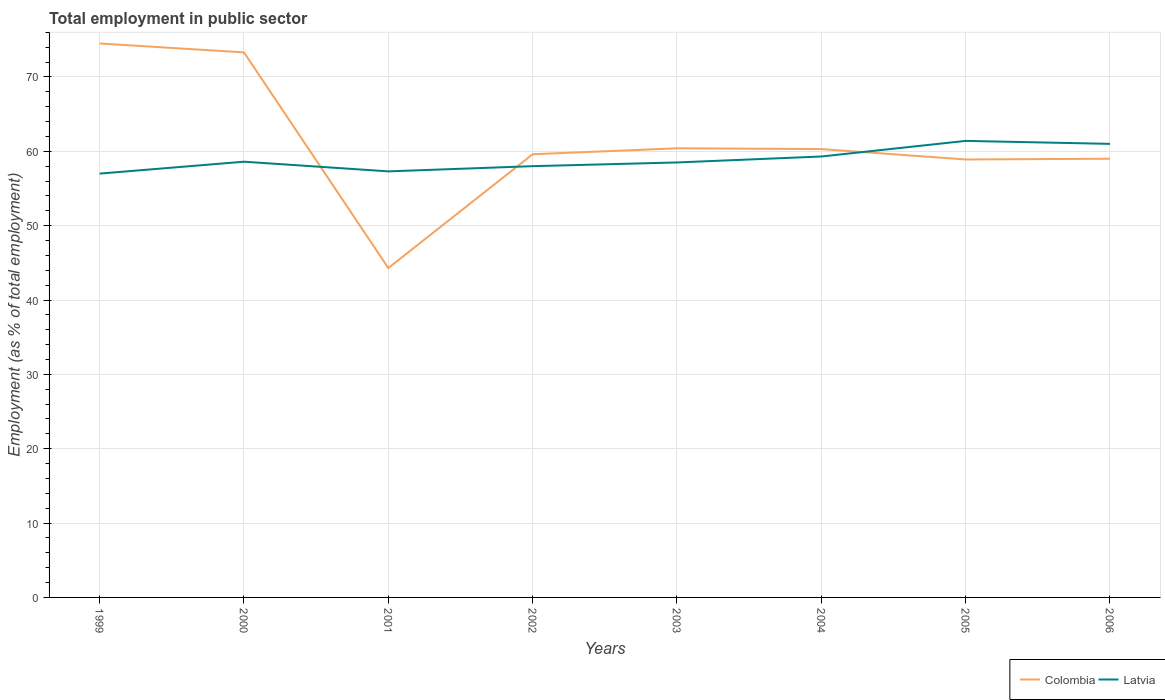How many different coloured lines are there?
Make the answer very short. 2. In which year was the employment in public sector in Colombia maximum?
Offer a very short reply. 2001. What is the total employment in public sector in Latvia in the graph?
Give a very brief answer. -1.6. What is the difference between the highest and the second highest employment in public sector in Colombia?
Offer a terse response. 30.2. What is the difference between the highest and the lowest employment in public sector in Colombia?
Your response must be concise. 2. Is the employment in public sector in Colombia strictly greater than the employment in public sector in Latvia over the years?
Make the answer very short. No. How many years are there in the graph?
Provide a short and direct response. 8. What is the difference between two consecutive major ticks on the Y-axis?
Give a very brief answer. 10. Are the values on the major ticks of Y-axis written in scientific E-notation?
Your answer should be compact. No. Does the graph contain any zero values?
Offer a very short reply. No. Does the graph contain grids?
Provide a short and direct response. Yes. Where does the legend appear in the graph?
Your answer should be compact. Bottom right. How many legend labels are there?
Ensure brevity in your answer.  2. What is the title of the graph?
Ensure brevity in your answer.  Total employment in public sector. Does "United Kingdom" appear as one of the legend labels in the graph?
Make the answer very short. No. What is the label or title of the X-axis?
Your response must be concise. Years. What is the label or title of the Y-axis?
Keep it short and to the point. Employment (as % of total employment). What is the Employment (as % of total employment) of Colombia in 1999?
Keep it short and to the point. 74.5. What is the Employment (as % of total employment) of Colombia in 2000?
Your answer should be very brief. 73.3. What is the Employment (as % of total employment) in Latvia in 2000?
Your response must be concise. 58.6. What is the Employment (as % of total employment) of Colombia in 2001?
Keep it short and to the point. 44.3. What is the Employment (as % of total employment) of Latvia in 2001?
Provide a short and direct response. 57.3. What is the Employment (as % of total employment) in Colombia in 2002?
Your response must be concise. 59.6. What is the Employment (as % of total employment) in Latvia in 2002?
Provide a succinct answer. 58. What is the Employment (as % of total employment) in Colombia in 2003?
Your answer should be very brief. 60.4. What is the Employment (as % of total employment) in Latvia in 2003?
Give a very brief answer. 58.5. What is the Employment (as % of total employment) in Colombia in 2004?
Keep it short and to the point. 60.3. What is the Employment (as % of total employment) of Latvia in 2004?
Ensure brevity in your answer.  59.3. What is the Employment (as % of total employment) of Colombia in 2005?
Give a very brief answer. 58.9. What is the Employment (as % of total employment) of Latvia in 2005?
Make the answer very short. 61.4. What is the Employment (as % of total employment) in Latvia in 2006?
Offer a terse response. 61. Across all years, what is the maximum Employment (as % of total employment) in Colombia?
Offer a terse response. 74.5. Across all years, what is the maximum Employment (as % of total employment) in Latvia?
Provide a short and direct response. 61.4. Across all years, what is the minimum Employment (as % of total employment) in Colombia?
Your answer should be compact. 44.3. What is the total Employment (as % of total employment) in Colombia in the graph?
Offer a very short reply. 490.3. What is the total Employment (as % of total employment) in Latvia in the graph?
Offer a very short reply. 471.1. What is the difference between the Employment (as % of total employment) in Latvia in 1999 and that in 2000?
Provide a succinct answer. -1.6. What is the difference between the Employment (as % of total employment) of Colombia in 1999 and that in 2001?
Offer a terse response. 30.2. What is the difference between the Employment (as % of total employment) of Latvia in 1999 and that in 2002?
Provide a short and direct response. -1. What is the difference between the Employment (as % of total employment) of Colombia in 1999 and that in 2004?
Your answer should be compact. 14.2. What is the difference between the Employment (as % of total employment) in Colombia in 1999 and that in 2005?
Make the answer very short. 15.6. What is the difference between the Employment (as % of total employment) in Colombia in 1999 and that in 2006?
Your answer should be compact. 15.5. What is the difference between the Employment (as % of total employment) of Colombia in 2000 and that in 2004?
Make the answer very short. 13. What is the difference between the Employment (as % of total employment) in Latvia in 2000 and that in 2005?
Your answer should be compact. -2.8. What is the difference between the Employment (as % of total employment) of Colombia in 2000 and that in 2006?
Give a very brief answer. 14.3. What is the difference between the Employment (as % of total employment) in Latvia in 2000 and that in 2006?
Make the answer very short. -2.4. What is the difference between the Employment (as % of total employment) of Colombia in 2001 and that in 2002?
Ensure brevity in your answer.  -15.3. What is the difference between the Employment (as % of total employment) of Colombia in 2001 and that in 2003?
Your answer should be very brief. -16.1. What is the difference between the Employment (as % of total employment) of Colombia in 2001 and that in 2004?
Ensure brevity in your answer.  -16. What is the difference between the Employment (as % of total employment) in Colombia in 2001 and that in 2005?
Offer a terse response. -14.6. What is the difference between the Employment (as % of total employment) of Colombia in 2001 and that in 2006?
Ensure brevity in your answer.  -14.7. What is the difference between the Employment (as % of total employment) in Latvia in 2001 and that in 2006?
Offer a very short reply. -3.7. What is the difference between the Employment (as % of total employment) of Latvia in 2002 and that in 2003?
Offer a terse response. -0.5. What is the difference between the Employment (as % of total employment) of Colombia in 2002 and that in 2006?
Make the answer very short. 0.6. What is the difference between the Employment (as % of total employment) of Latvia in 2002 and that in 2006?
Provide a succinct answer. -3. What is the difference between the Employment (as % of total employment) of Latvia in 2003 and that in 2004?
Offer a very short reply. -0.8. What is the difference between the Employment (as % of total employment) of Latvia in 2003 and that in 2005?
Give a very brief answer. -2.9. What is the difference between the Employment (as % of total employment) in Latvia in 2003 and that in 2006?
Provide a short and direct response. -2.5. What is the difference between the Employment (as % of total employment) of Colombia in 2004 and that in 2005?
Make the answer very short. 1.4. What is the difference between the Employment (as % of total employment) in Latvia in 2004 and that in 2005?
Ensure brevity in your answer.  -2.1. What is the difference between the Employment (as % of total employment) of Latvia in 2004 and that in 2006?
Your answer should be compact. -1.7. What is the difference between the Employment (as % of total employment) in Colombia in 2005 and that in 2006?
Offer a terse response. -0.1. What is the difference between the Employment (as % of total employment) of Latvia in 2005 and that in 2006?
Offer a very short reply. 0.4. What is the difference between the Employment (as % of total employment) of Colombia in 1999 and the Employment (as % of total employment) of Latvia in 2001?
Provide a short and direct response. 17.2. What is the difference between the Employment (as % of total employment) of Colombia in 1999 and the Employment (as % of total employment) of Latvia in 2005?
Keep it short and to the point. 13.1. What is the difference between the Employment (as % of total employment) of Colombia in 2000 and the Employment (as % of total employment) of Latvia in 2003?
Offer a very short reply. 14.8. What is the difference between the Employment (as % of total employment) in Colombia in 2000 and the Employment (as % of total employment) in Latvia in 2004?
Provide a short and direct response. 14. What is the difference between the Employment (as % of total employment) in Colombia in 2000 and the Employment (as % of total employment) in Latvia in 2005?
Give a very brief answer. 11.9. What is the difference between the Employment (as % of total employment) of Colombia in 2000 and the Employment (as % of total employment) of Latvia in 2006?
Keep it short and to the point. 12.3. What is the difference between the Employment (as % of total employment) of Colombia in 2001 and the Employment (as % of total employment) of Latvia in 2002?
Your answer should be very brief. -13.7. What is the difference between the Employment (as % of total employment) of Colombia in 2001 and the Employment (as % of total employment) of Latvia in 2005?
Offer a very short reply. -17.1. What is the difference between the Employment (as % of total employment) of Colombia in 2001 and the Employment (as % of total employment) of Latvia in 2006?
Ensure brevity in your answer.  -16.7. What is the difference between the Employment (as % of total employment) in Colombia in 2002 and the Employment (as % of total employment) in Latvia in 2004?
Your answer should be very brief. 0.3. What is the difference between the Employment (as % of total employment) of Colombia in 2002 and the Employment (as % of total employment) of Latvia in 2005?
Offer a very short reply. -1.8. What is the difference between the Employment (as % of total employment) of Colombia in 2002 and the Employment (as % of total employment) of Latvia in 2006?
Ensure brevity in your answer.  -1.4. What is the difference between the Employment (as % of total employment) in Colombia in 2003 and the Employment (as % of total employment) in Latvia in 2004?
Provide a short and direct response. 1.1. What is the average Employment (as % of total employment) of Colombia per year?
Your answer should be very brief. 61.29. What is the average Employment (as % of total employment) of Latvia per year?
Offer a terse response. 58.89. In the year 1999, what is the difference between the Employment (as % of total employment) in Colombia and Employment (as % of total employment) in Latvia?
Keep it short and to the point. 17.5. In the year 2002, what is the difference between the Employment (as % of total employment) of Colombia and Employment (as % of total employment) of Latvia?
Your answer should be compact. 1.6. In the year 2004, what is the difference between the Employment (as % of total employment) in Colombia and Employment (as % of total employment) in Latvia?
Your answer should be very brief. 1. What is the ratio of the Employment (as % of total employment) in Colombia in 1999 to that in 2000?
Ensure brevity in your answer.  1.02. What is the ratio of the Employment (as % of total employment) in Latvia in 1999 to that in 2000?
Make the answer very short. 0.97. What is the ratio of the Employment (as % of total employment) of Colombia in 1999 to that in 2001?
Make the answer very short. 1.68. What is the ratio of the Employment (as % of total employment) of Colombia in 1999 to that in 2002?
Offer a terse response. 1.25. What is the ratio of the Employment (as % of total employment) of Latvia in 1999 to that in 2002?
Offer a terse response. 0.98. What is the ratio of the Employment (as % of total employment) of Colombia in 1999 to that in 2003?
Provide a succinct answer. 1.23. What is the ratio of the Employment (as % of total employment) of Latvia in 1999 to that in 2003?
Your answer should be compact. 0.97. What is the ratio of the Employment (as % of total employment) of Colombia in 1999 to that in 2004?
Provide a succinct answer. 1.24. What is the ratio of the Employment (as % of total employment) of Latvia in 1999 to that in 2004?
Make the answer very short. 0.96. What is the ratio of the Employment (as % of total employment) in Colombia in 1999 to that in 2005?
Your response must be concise. 1.26. What is the ratio of the Employment (as % of total employment) of Latvia in 1999 to that in 2005?
Give a very brief answer. 0.93. What is the ratio of the Employment (as % of total employment) in Colombia in 1999 to that in 2006?
Provide a succinct answer. 1.26. What is the ratio of the Employment (as % of total employment) in Latvia in 1999 to that in 2006?
Provide a short and direct response. 0.93. What is the ratio of the Employment (as % of total employment) in Colombia in 2000 to that in 2001?
Offer a very short reply. 1.65. What is the ratio of the Employment (as % of total employment) of Latvia in 2000 to that in 2001?
Make the answer very short. 1.02. What is the ratio of the Employment (as % of total employment) in Colombia in 2000 to that in 2002?
Make the answer very short. 1.23. What is the ratio of the Employment (as % of total employment) of Latvia in 2000 to that in 2002?
Your answer should be compact. 1.01. What is the ratio of the Employment (as % of total employment) in Colombia in 2000 to that in 2003?
Make the answer very short. 1.21. What is the ratio of the Employment (as % of total employment) of Latvia in 2000 to that in 2003?
Your answer should be very brief. 1. What is the ratio of the Employment (as % of total employment) in Colombia in 2000 to that in 2004?
Make the answer very short. 1.22. What is the ratio of the Employment (as % of total employment) in Latvia in 2000 to that in 2004?
Ensure brevity in your answer.  0.99. What is the ratio of the Employment (as % of total employment) in Colombia in 2000 to that in 2005?
Ensure brevity in your answer.  1.24. What is the ratio of the Employment (as % of total employment) in Latvia in 2000 to that in 2005?
Provide a succinct answer. 0.95. What is the ratio of the Employment (as % of total employment) in Colombia in 2000 to that in 2006?
Make the answer very short. 1.24. What is the ratio of the Employment (as % of total employment) of Latvia in 2000 to that in 2006?
Your answer should be very brief. 0.96. What is the ratio of the Employment (as % of total employment) in Colombia in 2001 to that in 2002?
Provide a succinct answer. 0.74. What is the ratio of the Employment (as % of total employment) in Latvia in 2001 to that in 2002?
Offer a very short reply. 0.99. What is the ratio of the Employment (as % of total employment) of Colombia in 2001 to that in 2003?
Make the answer very short. 0.73. What is the ratio of the Employment (as % of total employment) of Latvia in 2001 to that in 2003?
Provide a short and direct response. 0.98. What is the ratio of the Employment (as % of total employment) in Colombia in 2001 to that in 2004?
Provide a short and direct response. 0.73. What is the ratio of the Employment (as % of total employment) of Latvia in 2001 to that in 2004?
Provide a short and direct response. 0.97. What is the ratio of the Employment (as % of total employment) of Colombia in 2001 to that in 2005?
Your answer should be compact. 0.75. What is the ratio of the Employment (as % of total employment) in Latvia in 2001 to that in 2005?
Your answer should be very brief. 0.93. What is the ratio of the Employment (as % of total employment) of Colombia in 2001 to that in 2006?
Provide a succinct answer. 0.75. What is the ratio of the Employment (as % of total employment) in Latvia in 2001 to that in 2006?
Keep it short and to the point. 0.94. What is the ratio of the Employment (as % of total employment) in Colombia in 2002 to that in 2004?
Give a very brief answer. 0.99. What is the ratio of the Employment (as % of total employment) of Latvia in 2002 to that in 2004?
Offer a terse response. 0.98. What is the ratio of the Employment (as % of total employment) in Colombia in 2002 to that in 2005?
Ensure brevity in your answer.  1.01. What is the ratio of the Employment (as % of total employment) of Latvia in 2002 to that in 2005?
Ensure brevity in your answer.  0.94. What is the ratio of the Employment (as % of total employment) in Colombia in 2002 to that in 2006?
Provide a succinct answer. 1.01. What is the ratio of the Employment (as % of total employment) of Latvia in 2002 to that in 2006?
Keep it short and to the point. 0.95. What is the ratio of the Employment (as % of total employment) of Latvia in 2003 to that in 2004?
Your answer should be very brief. 0.99. What is the ratio of the Employment (as % of total employment) in Colombia in 2003 to that in 2005?
Your answer should be very brief. 1.03. What is the ratio of the Employment (as % of total employment) in Latvia in 2003 to that in 2005?
Give a very brief answer. 0.95. What is the ratio of the Employment (as % of total employment) in Colombia in 2003 to that in 2006?
Offer a terse response. 1.02. What is the ratio of the Employment (as % of total employment) of Colombia in 2004 to that in 2005?
Keep it short and to the point. 1.02. What is the ratio of the Employment (as % of total employment) in Latvia in 2004 to that in 2005?
Make the answer very short. 0.97. What is the ratio of the Employment (as % of total employment) of Latvia in 2004 to that in 2006?
Provide a succinct answer. 0.97. What is the ratio of the Employment (as % of total employment) of Colombia in 2005 to that in 2006?
Your answer should be compact. 1. What is the ratio of the Employment (as % of total employment) in Latvia in 2005 to that in 2006?
Offer a very short reply. 1.01. What is the difference between the highest and the second highest Employment (as % of total employment) of Colombia?
Provide a short and direct response. 1.2. What is the difference between the highest and the lowest Employment (as % of total employment) of Colombia?
Your answer should be compact. 30.2. 